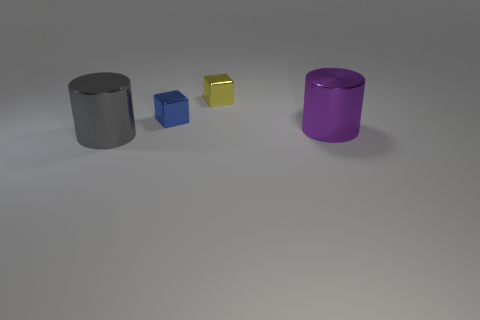Add 2 large purple cylinders. How many objects exist? 6 Add 4 small blue metal cubes. How many small blue metal cubes are left? 5 Add 2 purple cylinders. How many purple cylinders exist? 3 Subtract 0 yellow balls. How many objects are left? 4 Subtract all big cyan metallic blocks. Subtract all purple metallic cylinders. How many objects are left? 3 